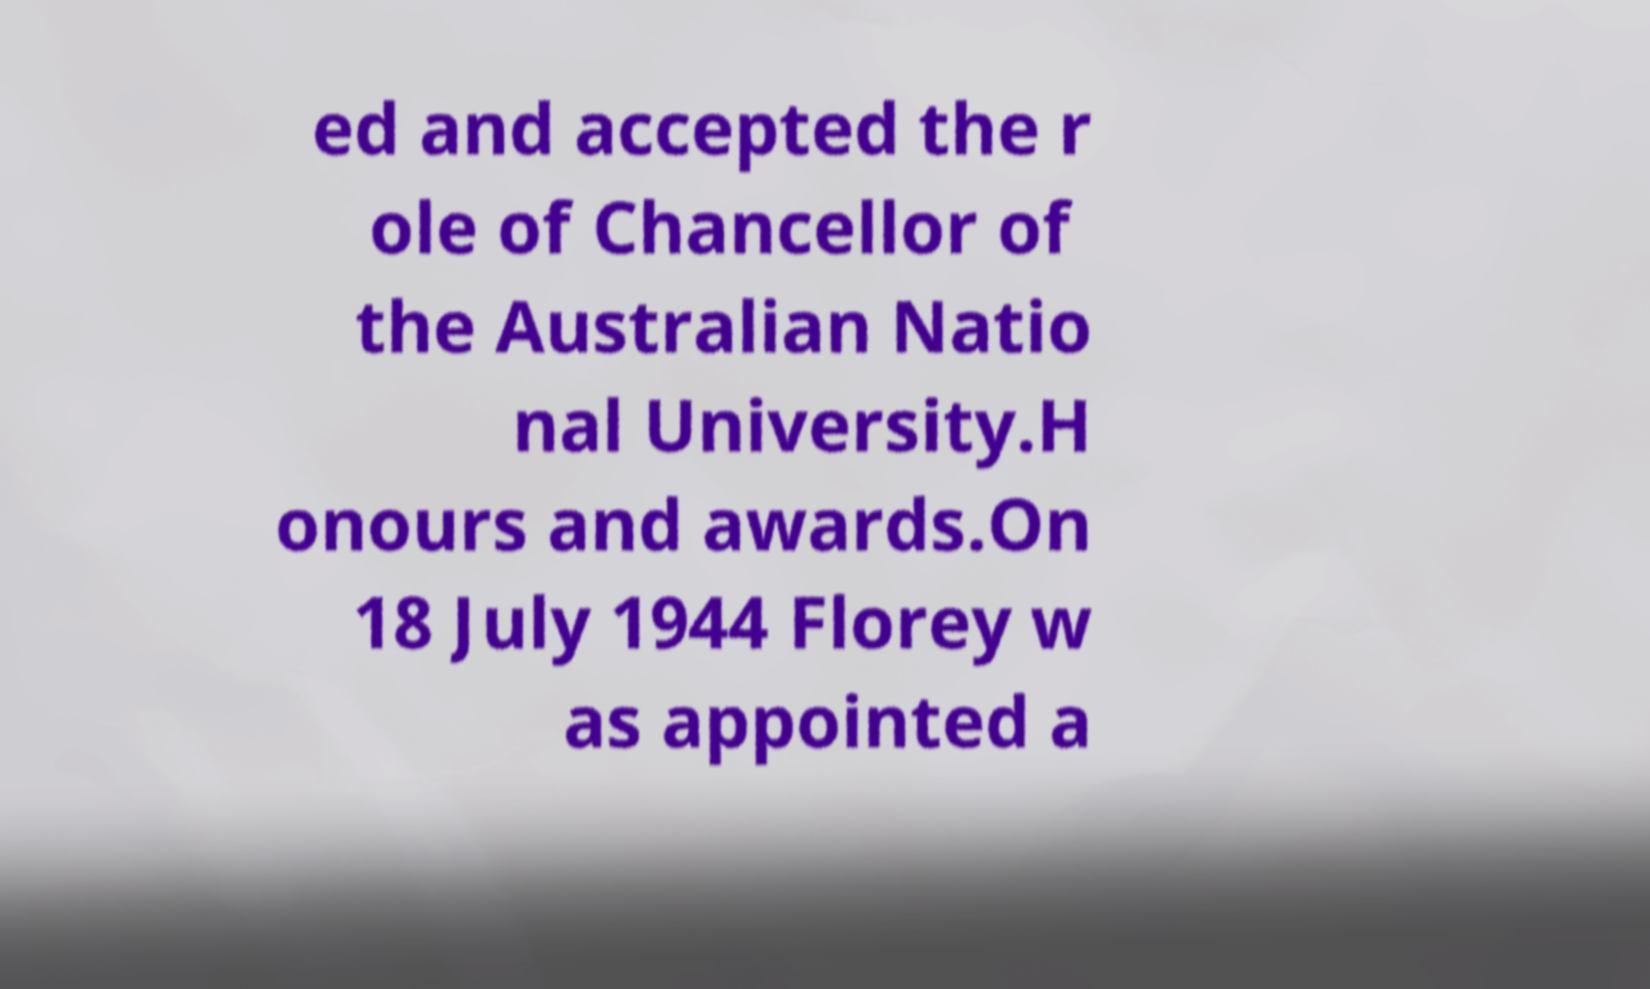What messages or text are displayed in this image? I need them in a readable, typed format. ed and accepted the r ole of Chancellor of the Australian Natio nal University.H onours and awards.On 18 July 1944 Florey w as appointed a 